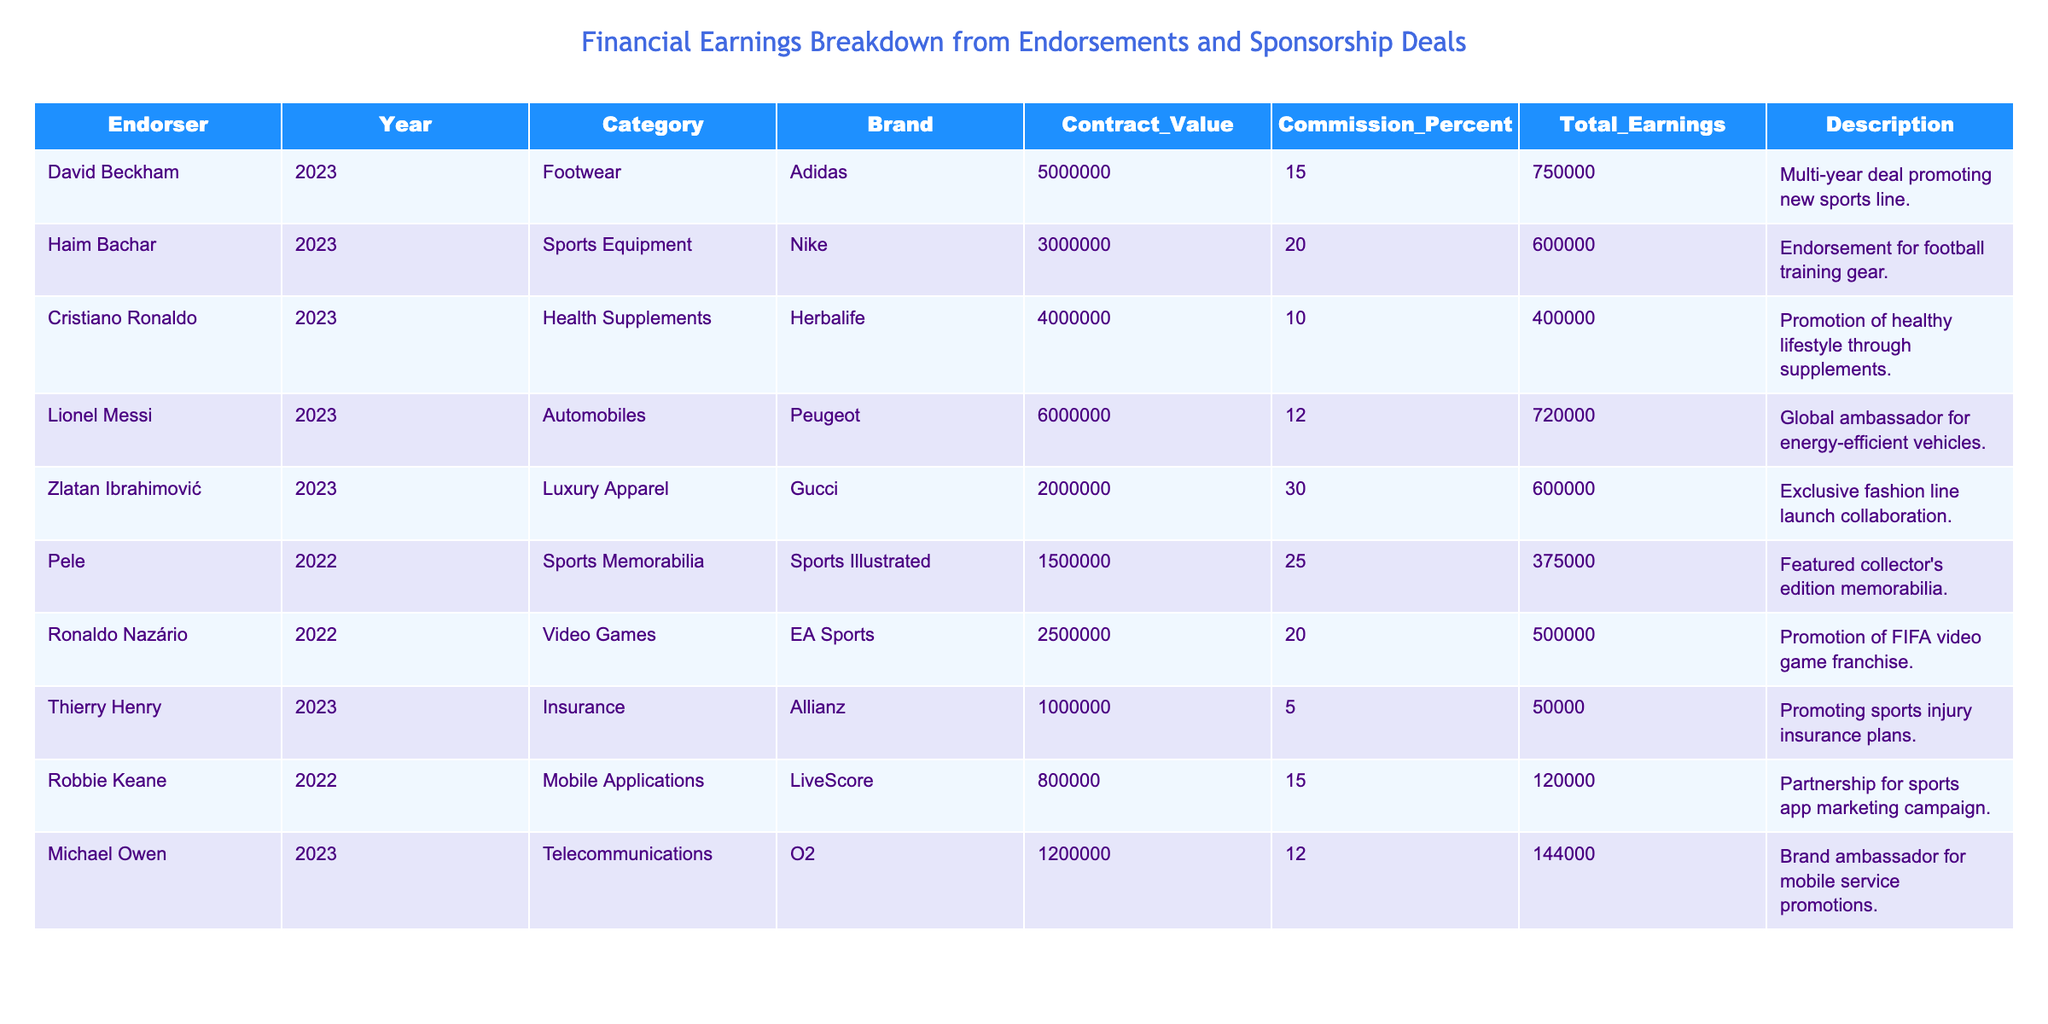What is the total contract value for Haim Bachar's endorsement deal? The table indicates that Haim Bachar's endorsement deal with Nike has a contract value of 3,000,000.
Answer: 3,000,000 Which brand did Lionel Messi endorse in 2023? According to the table, Lionel Messi endorsed Peugeot in 2023.
Answer: Peugeot What percentage commission did Cristiano Ronaldo earn from his deal? The table shows that Cristiano Ronaldo earned a commission of 10% from his endorsement deal with Herbalife.
Answer: 10% Who had the highest total earnings from endorsements listed in the table? By comparing total earnings, Lionel Messi earned 720,000, which is the highest compared to others like David Beckham (750,000) and Haim Bachar (600,000).
Answer: Lionel Messi What is the average total earnings of the endorsers in 2023? The total earnings for the endorsers in 2023 are 750,000 (David Beckham), 600,000 (Haim Bachar), 400,000 (Cristiano Ronaldo), 720,000 (Lionel Messi), 600,000 (Zlatan Ibrahimović), 50,000 (Thierry Henry), and 144,000 (Michael Owen), which sums to 3,264,000. Dividing by the number of endorsers (7) gives us an average of approximately 466,286.
Answer: Approximately 466,286 Did any endorser have a commission rate higher than 25%? The table shows that Zlatan Ibrahimović had a commission rate of 30%, which is indeed higher than 25%.
Answer: Yes What is the total value of contracts for all the listed endorsers in 2022? The total contract values for endorsers in 2022 are 1,500,000 (Pele) and 2,500,000 (Ronaldo Nazário), which sum to 4,000,000.
Answer: 4,000,000 If Pele's total earnings were 375,000, what was the commission percentage on his contract? To find the commission percentage, divide Pele's total earnings (375,000) by his contract value (1,500,000) and multiply by 100: (375,000 / 1,500,000) * 100 = 25%.
Answer: 25% Which endorser earned more than 600,000 total earnings? According to the table, the endorsers who earned more than 600,000 are David Beckham with 750,000 and Lionel Messi with 720,000.
Answer: David Beckham and Lionel Messi What is the difference in total earnings between Haim Bachar and Michael Owen? Haim Bachar earned 600,000 while Michael Owen earned 144,000. The difference is calculated as 600,000 - 144,000 = 456,000.
Answer: 456,000 Is there any endorser associated with a brand in the luxury apparel category? The table confirms that Zlatan Ibrahimović is associated with Gucci, a brand in the luxury apparel category.
Answer: Yes 